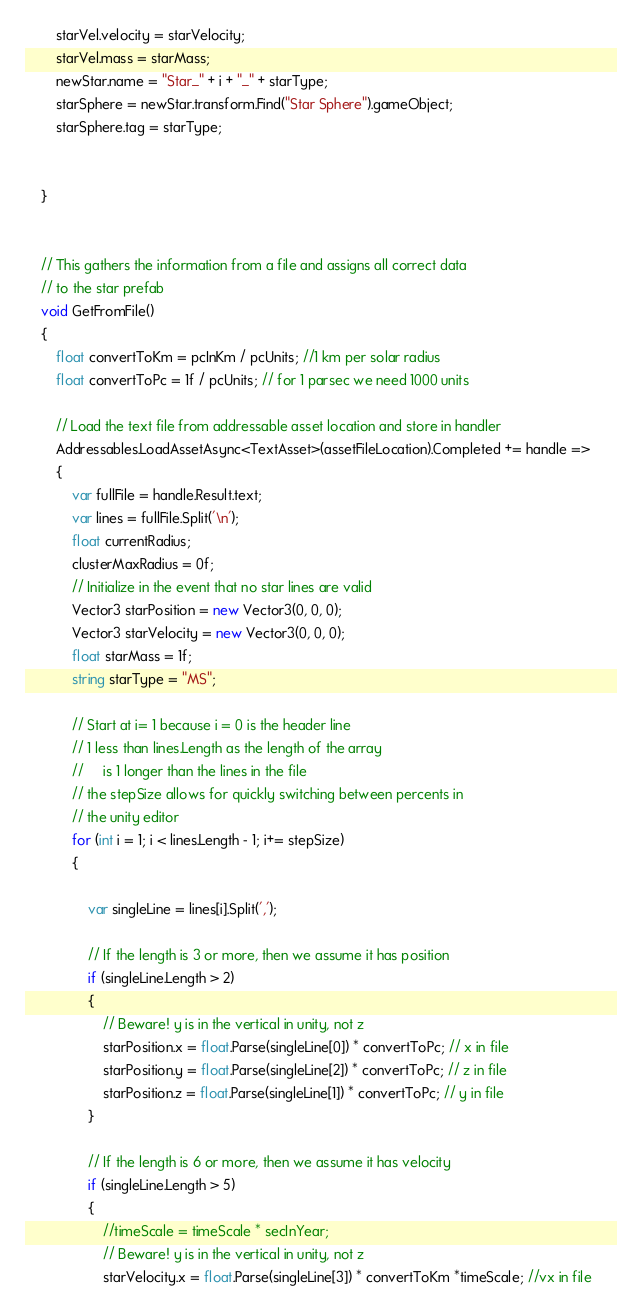<code> <loc_0><loc_0><loc_500><loc_500><_C#_>        starVel.velocity = starVelocity;
        starVel.mass = starMass;
        newStar.name = "Star_" + i + "_" + starType;
        starSphere = newStar.transform.Find("Star Sphere").gameObject;
        starSphere.tag = starType;


    }


    // This gathers the information from a file and assigns all correct data
    // to the star prefab
    void GetFromFile()
    {
        float convertToKm = pcInKm / pcUnits; //1 km per solar radius
        float convertToPc = 1f / pcUnits; // for 1 parsec we need 1000 units

        // Load the text file from addressable asset location and store in handler
        Addressables.LoadAssetAsync<TextAsset>(assetFileLocation).Completed += handle =>
        {
            var fullFile = handle.Result.text;
            var lines = fullFile.Split('\n');
            float currentRadius;
            clusterMaxRadius = 0f;
            // Initialize in the event that no star lines are valid
            Vector3 starPosition = new Vector3(0, 0, 0);
            Vector3 starVelocity = new Vector3(0, 0, 0);
            float starMass = 1f; 
            string starType = "MS";
                        
            // Start at i= 1 because i = 0 is the header line
            // 1 less than lines.Length as the length of the array 
            //     is 1 longer than the lines in the file
            // the stepSize allows for quickly switching between percents in 
            // the unity editor
            for (int i = 1; i < lines.Length - 1; i+= stepSize)
            {
                
                var singleLine = lines[i].Split(',');
                
                // If the length is 3 or more, then we assume it has position
                if (singleLine.Length > 2)
                {
                    // Beware! y is in the vertical in unity, not z
                    starPosition.x = float.Parse(singleLine[0]) * convertToPc; // x in file               
                    starPosition.y = float.Parse(singleLine[2]) * convertToPc; // z in file   
                    starPosition.z = float.Parse(singleLine[1]) * convertToPc; // y in file  
                }

                // If the length is 6 or more, then we assume it has velocity
                if (singleLine.Length > 5)
                {
                    //timeScale = timeScale * secInYear;
                    // Beware! y is in the vertical in unity, not z
                    starVelocity.x = float.Parse(singleLine[3]) * convertToKm *timeScale; //vx in file</code> 